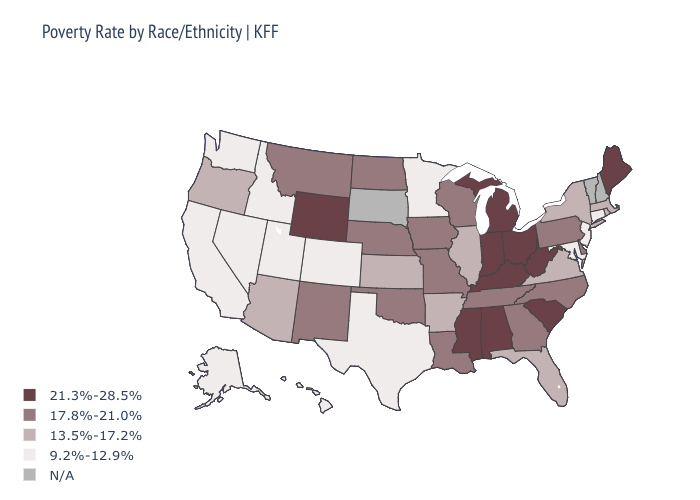Which states have the lowest value in the Northeast?
Keep it brief. Connecticut, New Jersey. What is the lowest value in states that border Kentucky?
Concise answer only. 13.5%-17.2%. Among the states that border Georgia , does South Carolina have the highest value?
Answer briefly. Yes. What is the value of Florida?
Keep it brief. 13.5%-17.2%. Which states have the lowest value in the USA?
Answer briefly. Alaska, California, Colorado, Connecticut, Hawaii, Idaho, Maryland, Minnesota, Nevada, New Jersey, Texas, Utah, Washington. Does Texas have the lowest value in the South?
Quick response, please. Yes. How many symbols are there in the legend?
Quick response, please. 5. What is the value of Tennessee?
Concise answer only. 17.8%-21.0%. Name the states that have a value in the range 21.3%-28.5%?
Quick response, please. Alabama, Indiana, Kentucky, Maine, Michigan, Mississippi, Ohio, South Carolina, West Virginia, Wyoming. Does the map have missing data?
Answer briefly. Yes. Name the states that have a value in the range 21.3%-28.5%?
Short answer required. Alabama, Indiana, Kentucky, Maine, Michigan, Mississippi, Ohio, South Carolina, West Virginia, Wyoming. What is the value of Maryland?
Short answer required. 9.2%-12.9%. Among the states that border New Hampshire , does Maine have the highest value?
Short answer required. Yes. 